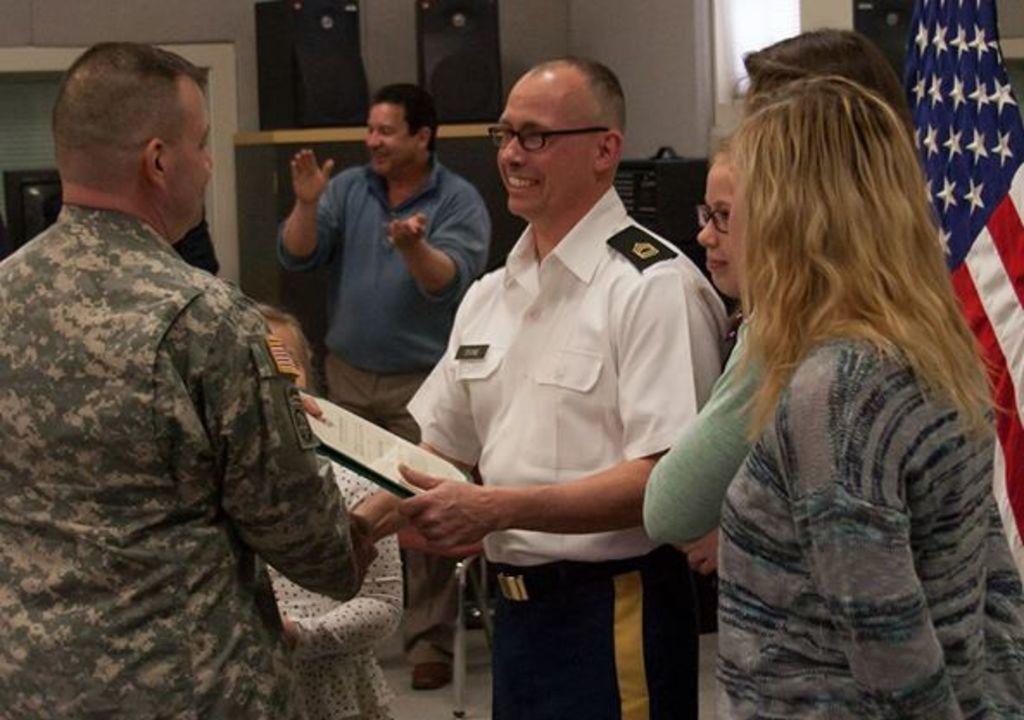Could you give a brief overview of what you see in this image? In this image, we can see people standing and some are wearing uniforms and holding a board and one of them is wearing glasses. In the background, we can see a flag and there are some boxes and there is a wall. 